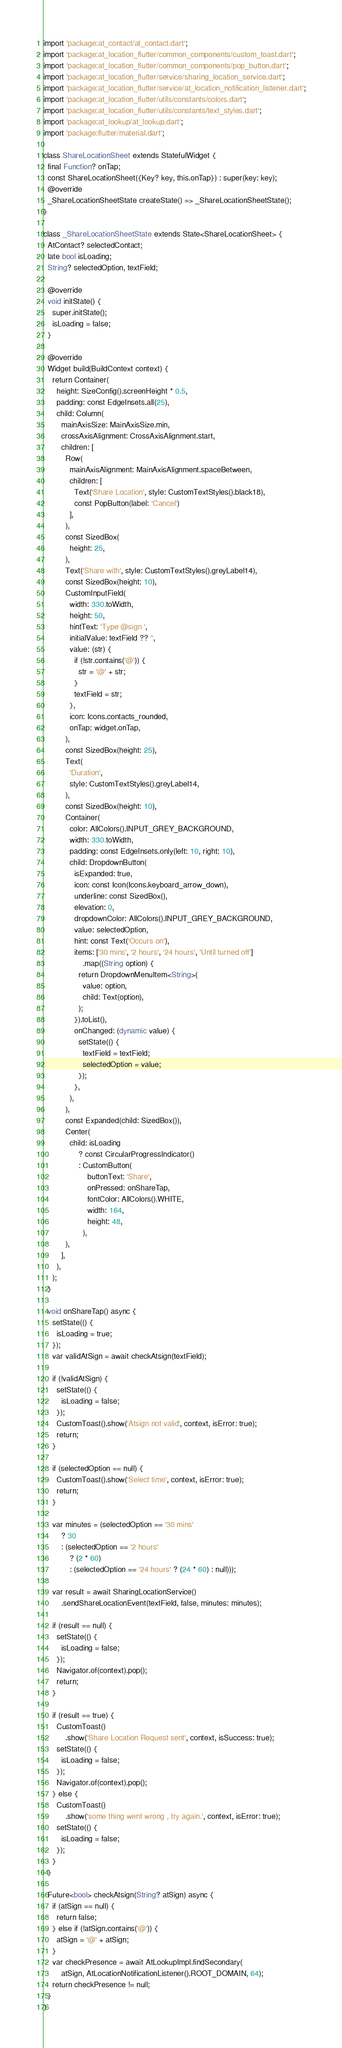Convert code to text. <code><loc_0><loc_0><loc_500><loc_500><_Dart_>import 'package:at_contact/at_contact.dart';
import 'package:at_location_flutter/common_components/custom_toast.dart';
import 'package:at_location_flutter/common_components/pop_button.dart';
import 'package:at_location_flutter/service/sharing_location_service.dart';
import 'package:at_location_flutter/service/at_location_notification_listener.dart';
import 'package:at_location_flutter/utils/constants/colors.dart';
import 'package:at_location_flutter/utils/constants/text_styles.dart';
import 'package:at_lookup/at_lookup.dart';
import 'package:flutter/material.dart';

class ShareLocationSheet extends StatefulWidget {
  final Function? onTap;
  const ShareLocationSheet({Key? key, this.onTap}) : super(key: key);
  @override
  _ShareLocationSheetState createState() => _ShareLocationSheetState();
}

class _ShareLocationSheetState extends State<ShareLocationSheet> {
  AtContact? selectedContact;
  late bool isLoading;
  String? selectedOption, textField;

  @override
  void initState() {
    super.initState();
    isLoading = false;
  }

  @override
  Widget build(BuildContext context) {
    return Container(
      height: SizeConfig().screenHeight * 0.5,
      padding: const EdgeInsets.all(25),
      child: Column(
        mainAxisSize: MainAxisSize.min,
        crossAxisAlignment: CrossAxisAlignment.start,
        children: [
          Row(
            mainAxisAlignment: MainAxisAlignment.spaceBetween,
            children: [
              Text('Share Location', style: CustomTextStyles().black18),
              const PopButton(label: 'Cancel')
            ],
          ),
          const SizedBox(
            height: 25,
          ),
          Text('Share with', style: CustomTextStyles().greyLabel14),
          const SizedBox(height: 10),
          CustomInputField(
            width: 330.toWidth,
            height: 50,
            hintText: 'Type @sign ',
            initialValue: textField ?? '',
            value: (str) {
              if (!str.contains('@')) {
                str = '@' + str;
              }
              textField = str;
            },
            icon: Icons.contacts_rounded,
            onTap: widget.onTap,
          ),
          const SizedBox(height: 25),
          Text(
            'Duration',
            style: CustomTextStyles().greyLabel14,
          ),
          const SizedBox(height: 10),
          Container(
            color: AllColors().INPUT_GREY_BACKGROUND,
            width: 330.toWidth,
            padding: const EdgeInsets.only(left: 10, right: 10),
            child: DropdownButton(
              isExpanded: true,
              icon: const Icon(Icons.keyboard_arrow_down),
              underline: const SizedBox(),
              elevation: 0,
              dropdownColor: AllColors().INPUT_GREY_BACKGROUND,
              value: selectedOption,
              hint: const Text('Occurs on'),
              items: ['30 mins', '2 hours', '24 hours', 'Until turned off']
                  .map((String option) {
                return DropdownMenuItem<String>(
                  value: option,
                  child: Text(option),
                );
              }).toList(),
              onChanged: (dynamic value) {
                setState(() {
                  textField = textField;
                  selectedOption = value;
                });
              },
            ),
          ),
          const Expanded(child: SizedBox()),
          Center(
            child: isLoading
                ? const CircularProgressIndicator()
                : CustomButton(
                    buttonText: 'Share',
                    onPressed: onShareTap,
                    fontColor: AllColors().WHITE,
                    width: 164,
                    height: 48,
                  ),
          ),
        ],
      ),
    );
  }

  void onShareTap() async {
    setState(() {
      isLoading = true;
    });
    var validAtSign = await checkAtsign(textField);

    if (!validAtSign) {
      setState(() {
        isLoading = false;
      });
      CustomToast().show('Atsign not valid', context, isError: true);
      return;
    }

    if (selectedOption == null) {
      CustomToast().show('Select time', context, isError: true);
      return;
    }

    var minutes = (selectedOption == '30 mins'
        ? 30
        : (selectedOption == '2 hours'
            ? (2 * 60)
            : (selectedOption == '24 hours' ? (24 * 60) : null)));

    var result = await SharingLocationService()
        .sendShareLocationEvent(textField, false, minutes: minutes);

    if (result == null) {
      setState(() {
        isLoading = false;
      });
      Navigator.of(context).pop();
      return;
    }

    if (result == true) {
      CustomToast()
          .show('Share Location Request sent', context, isSuccess: true);
      setState(() {
        isLoading = false;
      });
      Navigator.of(context).pop();
    } else {
      CustomToast()
          .show('some thing went wrong , try again.', context, isError: true);
      setState(() {
        isLoading = false;
      });
    }
  }

  Future<bool> checkAtsign(String? atSign) async {
    if (atSign == null) {
      return false;
    } else if (!atSign.contains('@')) {
      atSign = '@' + atSign;
    }
    var checkPresence = await AtLookupImpl.findSecondary(
        atSign, AtLocationNotificationListener().ROOT_DOMAIN, 64);
    return checkPresence != null;
  }
}
</code> 